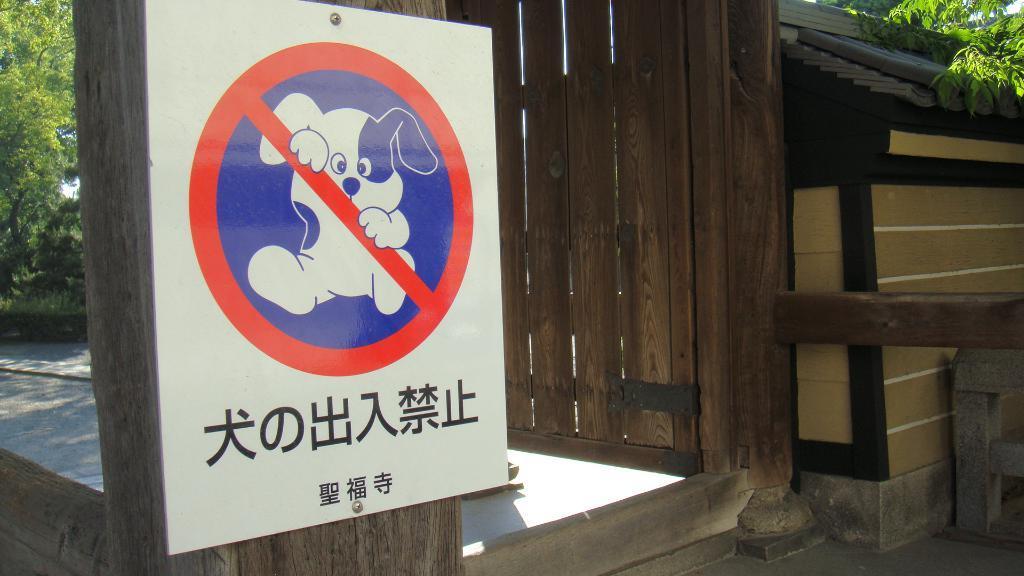Describe this image in one or two sentences. In this picture there is a house and there is a board on the pole and there is a picture of a dog and there is text on the board. At the back there are trees. At the bottom there is a floor. At the top it looks like sky. 